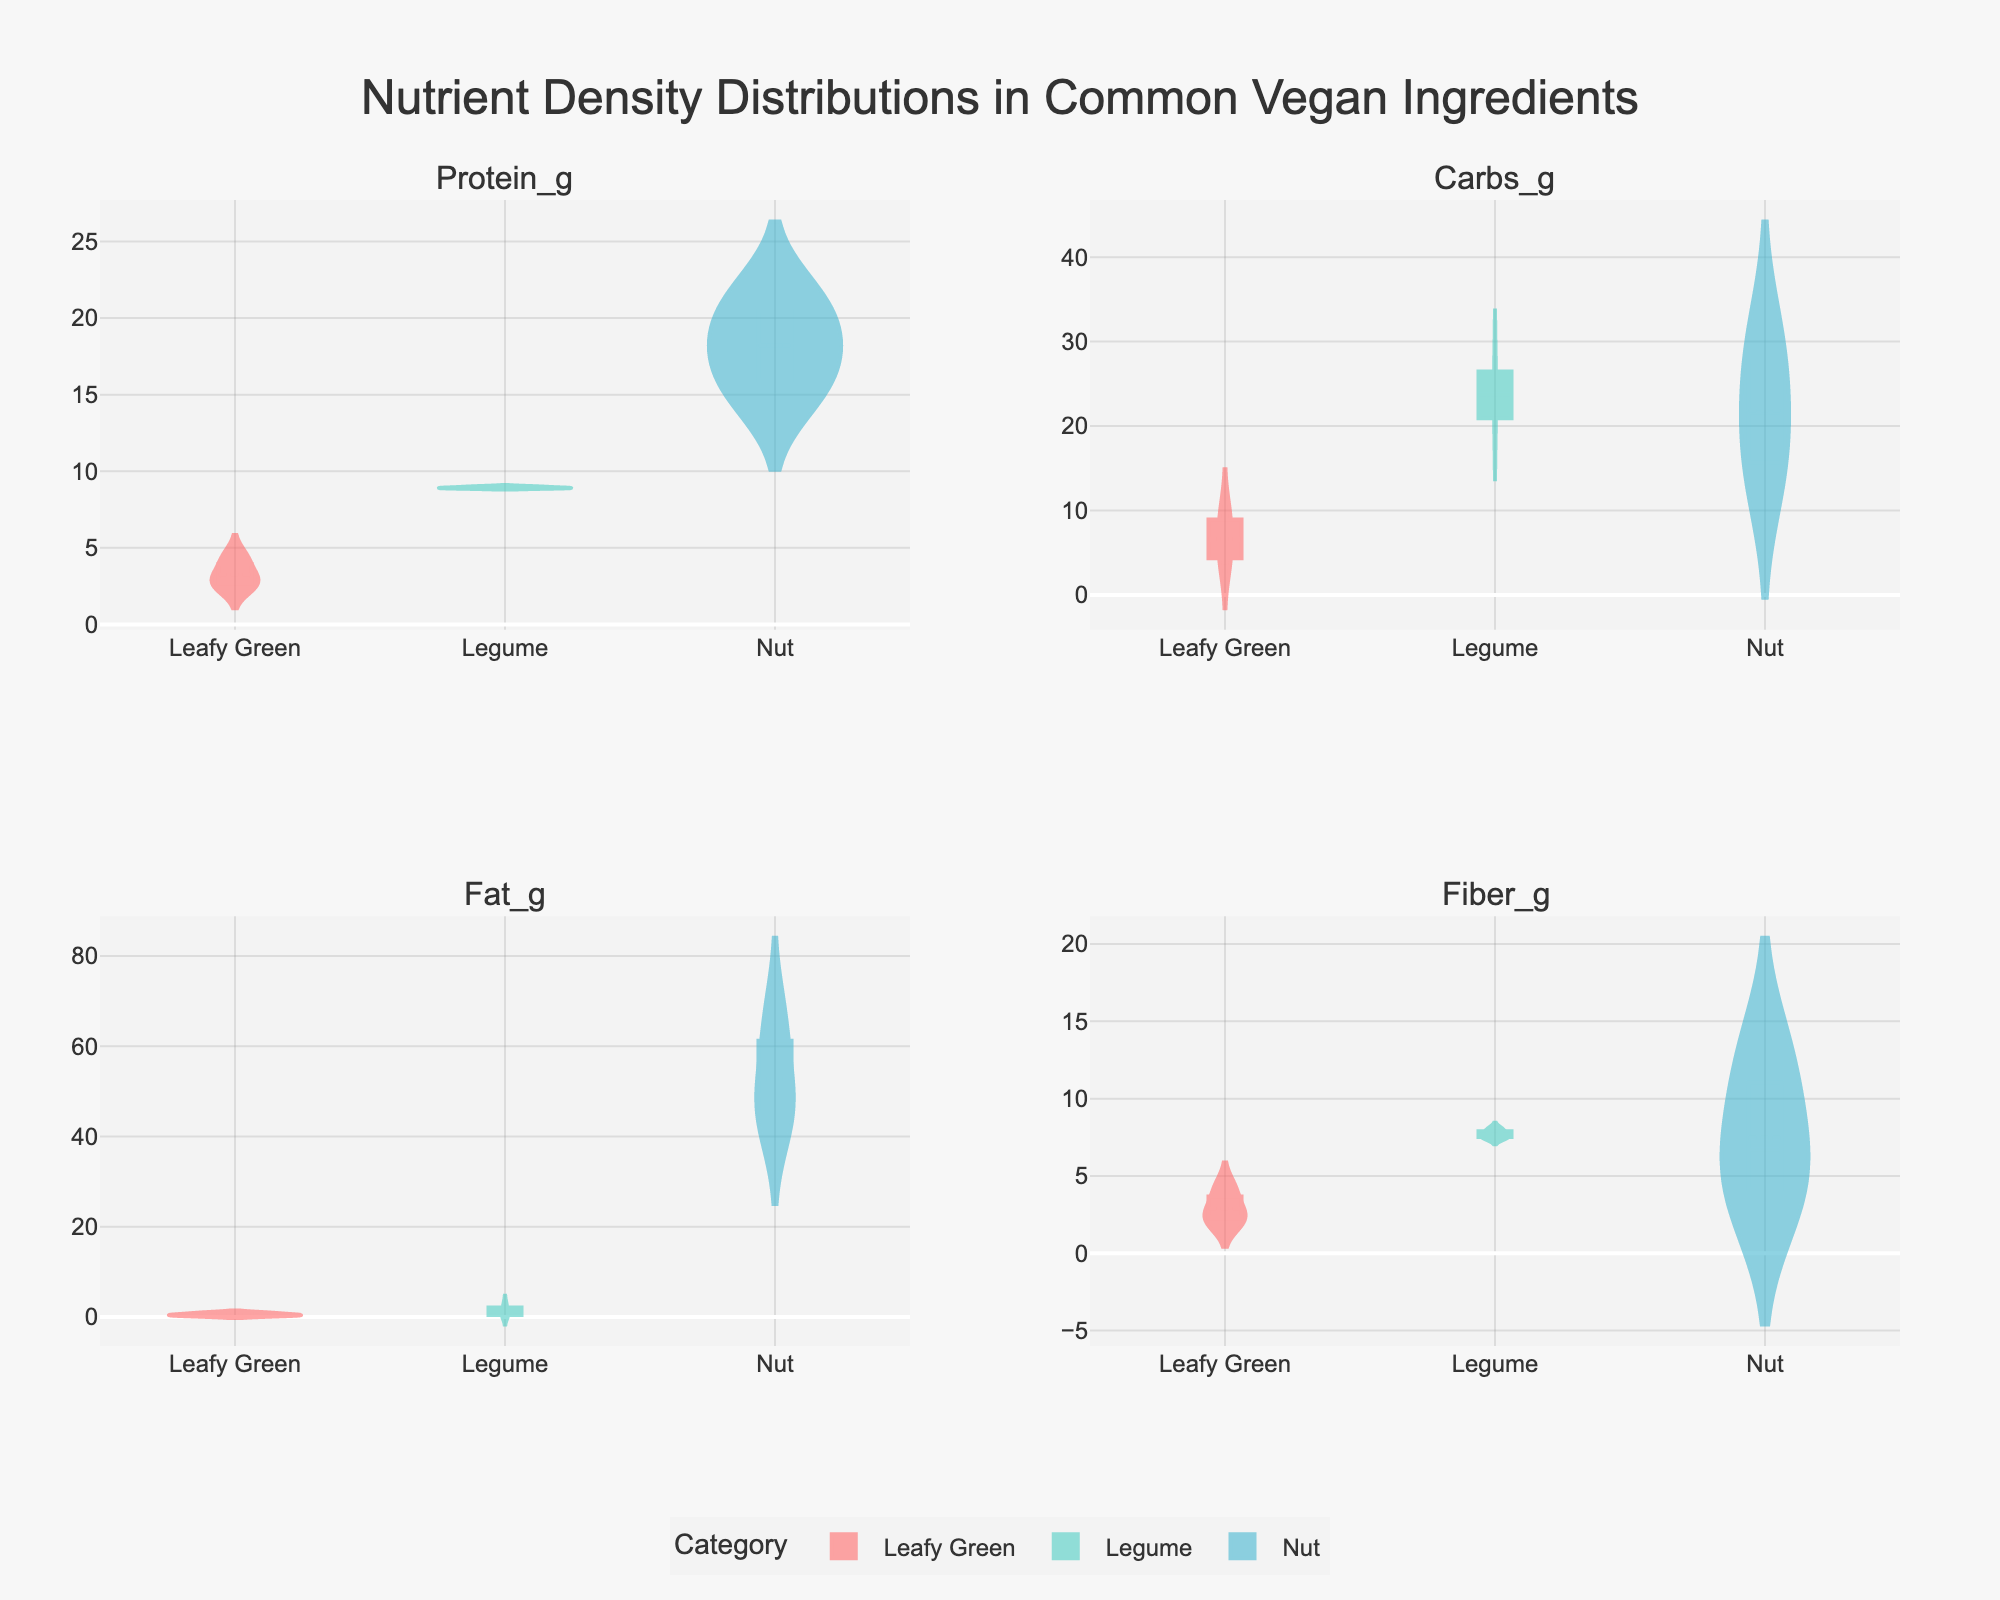What is the title of the figure? The title is located at the top of the figure, containing the main description of what the figure represents.
Answer: Nutrient Density Distributions in Common Vegan Ingredients Which category shows a higher variance in Protein_g content based on the density plot? To determine the variance, visually inspect the spread of the density plot for the Protein_g subplot. The wider and less peaked the distribution, the higher the variance.
Answer: Nut Which category tends to have higher Calcium_mg content: Leafy Greens or Nuts? By comparing the violin plots for Calcium_mg content across Leafy Greens and Nuts, check which has generally higher values.
Answer: Nuts How does the average Carbs_g content compare between Legumes and Nuts? Look at the position of the mean lines on the Carbs_g subplot for Legumes and Nuts. The category with a higher mean line has a higher average Carbs_g content.
Answer: Nuts Which category has the largest range in Fat_g content? Examine the Fat_g subplot and identify the category with the widest spread in the density plot for Fat_g. The category with the largest spread shows the largest range.
Answer: Nuts What is the median Fiber_g content for Legumes? Locate the mean line for Legumes in the Fiber_g subplot. The median is the center of the distribution, typically aligned closely with the mean for symmetric distributions.
Answer: Approximately 7.5 Between Leafy Greens and Legumes, which category shows a higher peak in Protein_g content density? Identify the peak heights in the Protein_g subplot for both Leafy Greens and Legumes. The higher peak corresponds to a higher density.
Answer: Legumes Are there any categories that show a significant overlap in Fat_g content density? Look at the Fat_g subplot and compare the density plots for each category. Check if any of the distributions visibly overlap significantly.
Answer: Yes, Leafy Greens and Legumes Which nutrient shows the greatest difference in density distributions between Leafy Greens and Nuts? Visually compare the density distributions of each nutrient across Leafy Greens and Nuts. Identify where the distributions differ the most in terms of shape or spread.
Answer: Fat_g Do Legumes have a more consistent Carbs_g content compared to Nuts? Consistency can be inferred from how narrow and peaked the density plot is. Compare the width of the Carbs_g distributions for Legumes and Nuts.
Answer: Yes 